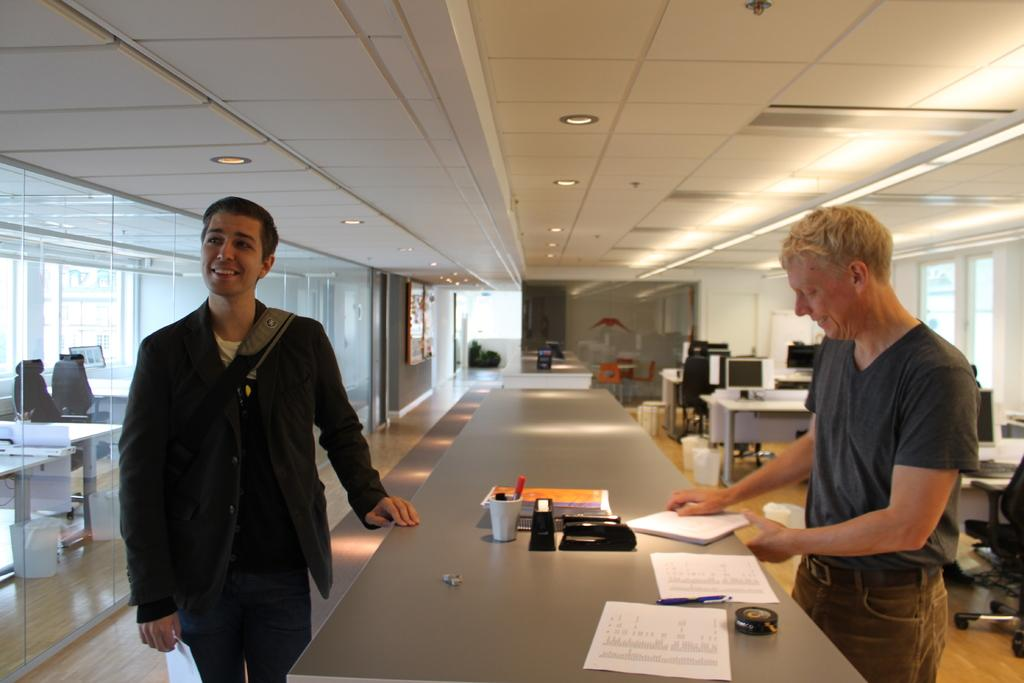How many people are in the image? There are two men standing in the image. What is present in the image besides the men? There is a table in the image, and the table has papers on it. What can be seen above the men and table in the image? There is a ceiling in the image. What is providing illumination in the image? There are lights visible in the image. What type of chicken is depicted on the flag in the image? There is no chicken or flag present in the image. What country's flag is being displayed in the image? There is no flag present in the image, so it is not possible to determine which country's flag might be displayed. 